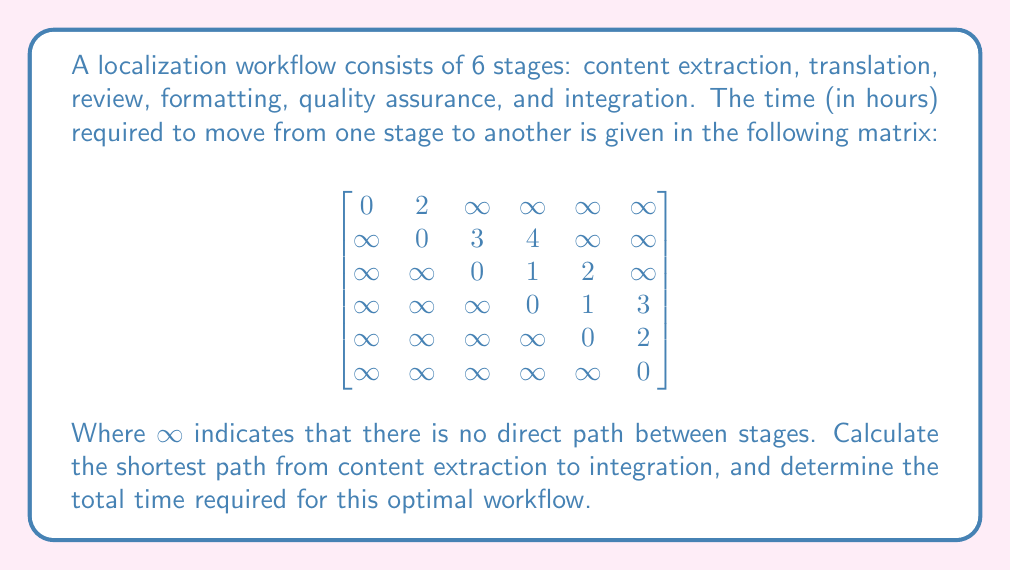Provide a solution to this math problem. To solve this problem, we can use Dijkstra's algorithm to find the shortest path in a weighted graph. Let's go through the steps:

1) Initialize distances:
   $d = [0, \infty, \infty, \infty, \infty, \infty]$
   $prev = [null, null, null, null, null, null]$

2) Set the starting node (content extraction) as current.

3) For the current node, consider all unvisited neighbors and calculate their tentative distances.
   
   From content extraction:
   $d[1] = \min(\infty, 0 + 2) = 2$
   $prev[1] = 0$

4) Mark content extraction as visited and set translation as the current node.

5) Repeat step 3 for translation:
   $d[2] = \min(\infty, 2 + 3) = 5$
   $prev[2] = 1$
   $d[3] = \min(\infty, 2 + 4) = 6$
   $prev[3] = 1$

6) Mark translation as visited and choose the unvisited node with the smallest tentative distance (review) as the current node.

7) From review:
   $d[3] = \min(6, 5 + 1) = 6$
   $prev[3] = 2$
   $d[4] = \min(\infty, 5 + 2) = 7$
   $prev[4] = 2$

8) Mark review as visited and set formatting as the current node.

9) From formatting:
   $d[4] = \min(7, 6 + 1) = 7$
   $prev[4] = 3$
   $d[5] = \min(\infty, 6 + 3) = 9$
   $prev[5] = 3$

10) Mark formatting as visited and set quality assurance as the current node.

11) From quality assurance:
    $d[5] = \min(9, 7 + 2) = 9$
    $prev[5] = 4$

12) Mark quality assurance as visited. Integration is the only unvisited node left, so it becomes the current node.

The shortest path is found by backtracking through the $prev$ array:
Integration <- Quality Assurance <- Formatting <- Review <- Translation <- Content Extraction

The total time is 9 hours.
Answer: The shortest path is: Content Extraction -> Translation -> Review -> Formatting -> Quality Assurance -> Integration. The total time required for this optimal workflow is 9 hours. 